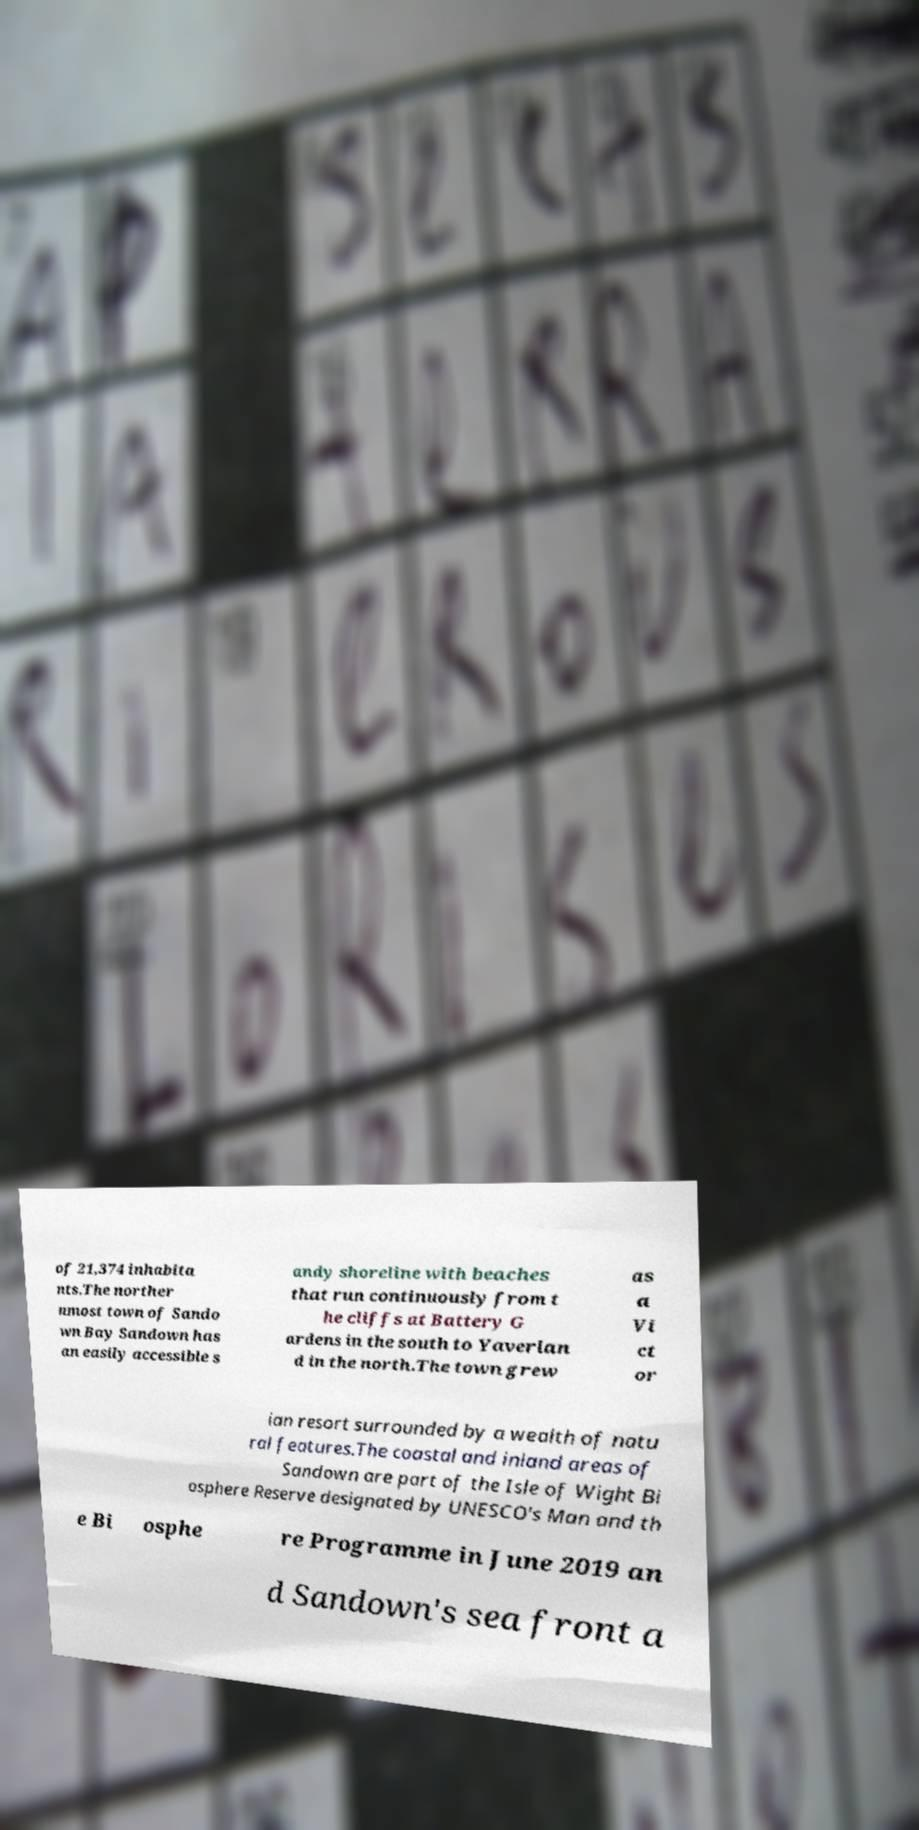Please identify and transcribe the text found in this image. of 21,374 inhabita nts.The norther nmost town of Sando wn Bay Sandown has an easily accessible s andy shoreline with beaches that run continuously from t he cliffs at Battery G ardens in the south to Yaverlan d in the north.The town grew as a Vi ct or ian resort surrounded by a wealth of natu ral features.The coastal and inland areas of Sandown are part of the Isle of Wight Bi osphere Reserve designated by UNESCO's Man and th e Bi osphe re Programme in June 2019 an d Sandown's sea front a 